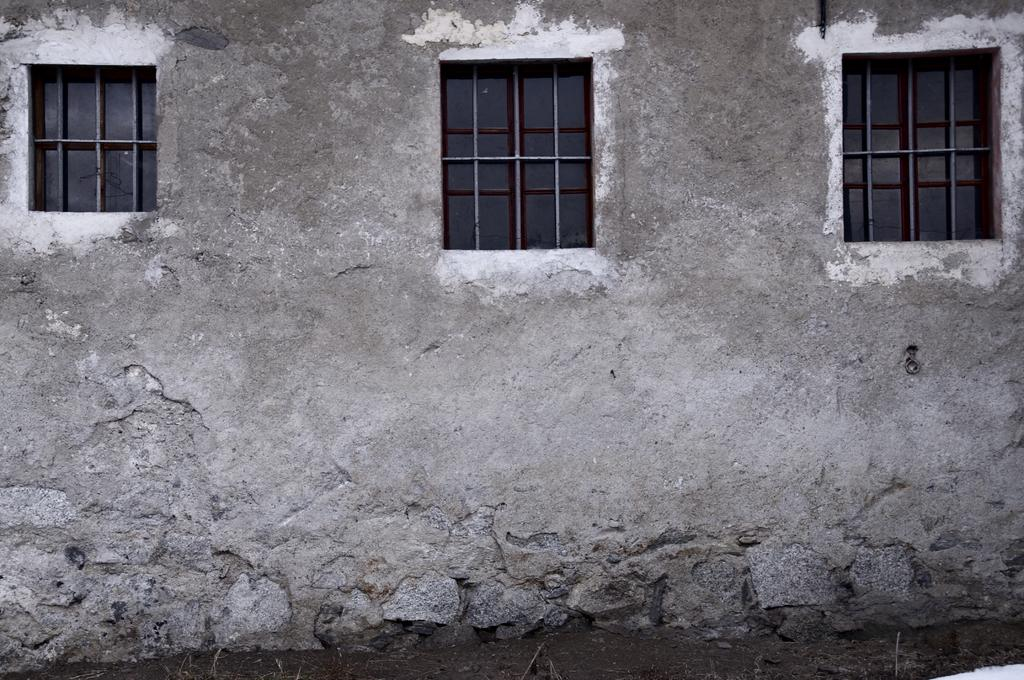What type of structure is visible in the image? There is a house in the image. What feature can be seen on the house? The house has windows. What else is present in the image besides the house? There is a wall in the image. What type of knot is tied on the skirt of the person standing next to the house in the image? There is no person or skirt present in the image; it only features a house and a wall. 